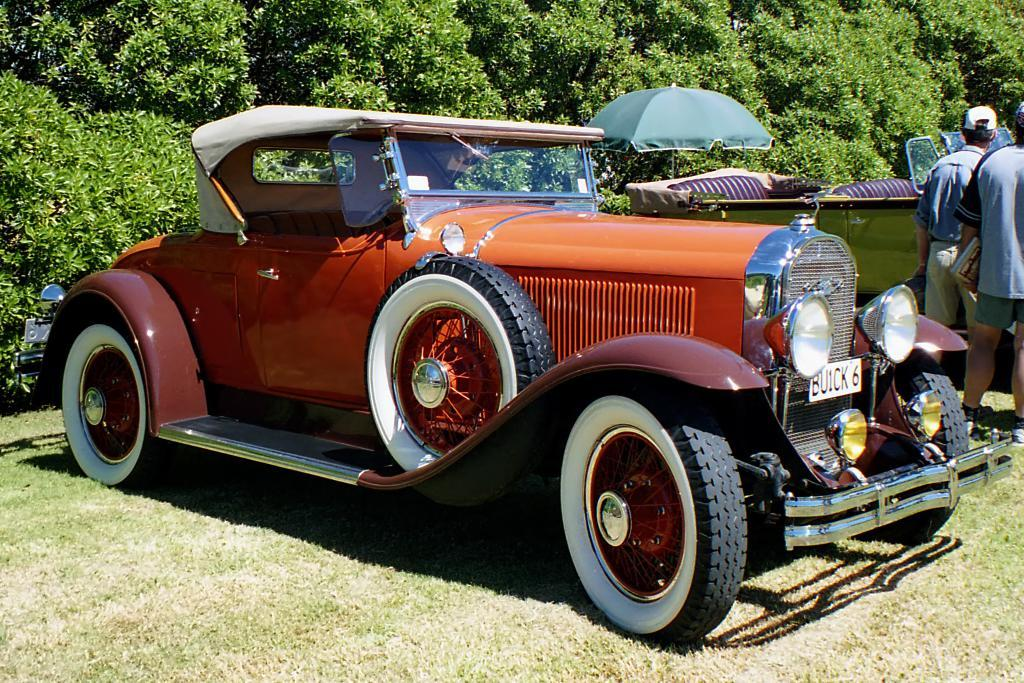What is located in the center of the image? There are vehicles and people standing in the center of the image. What object can be seen in the image that provides shade or protection from the elements? There is an umbrella in the image. What can be seen in the background of the image? There are trees in the background of the image. What is visible at the bottom of the image? The ground is visible at the bottom of the image. What type of badge is being worn by the air in the image? There is no air or badge present in the image. How does the middle of the image differ from the left and right sides? The middle of the image is not mentioned in the provided facts, so we cannot compare it to the left and right sides. 